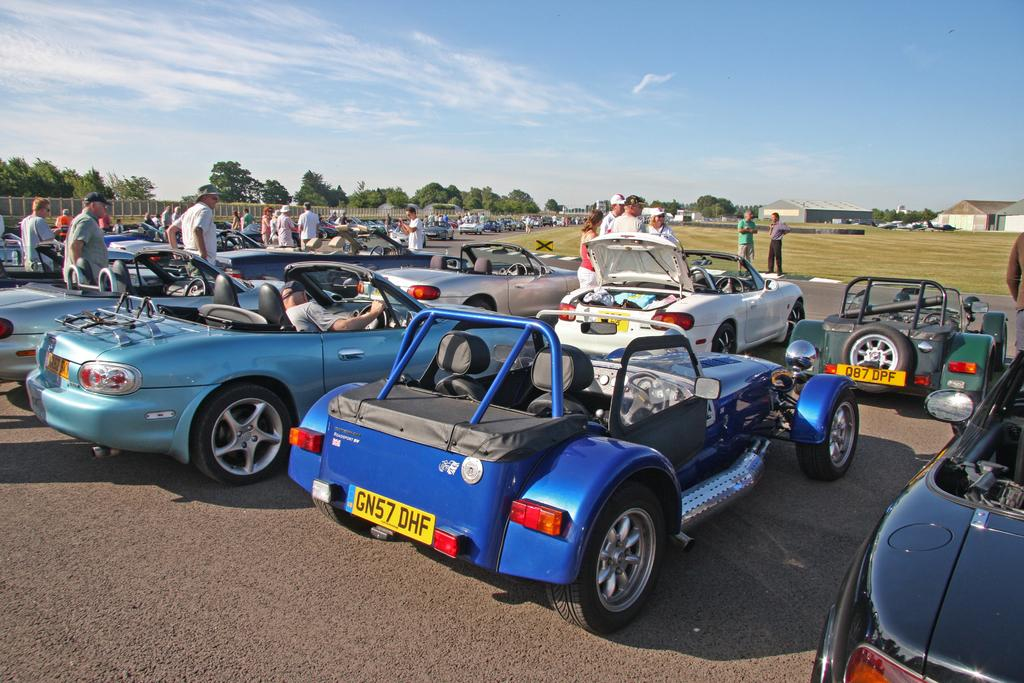What can be seen on the road in the image? There are cars parked on the road in the image. What are the people near the cars doing? There are people standing near the cars in the image. What is visible in the background of the image? There are trees and clouds in the sky in the background of the image. How many drawers are visible in the image? There are no drawers present in the image. What is causing the cars to burn in the image? There is no indication of cars burning in the image; the cars are parked and appear to be in good condition. 